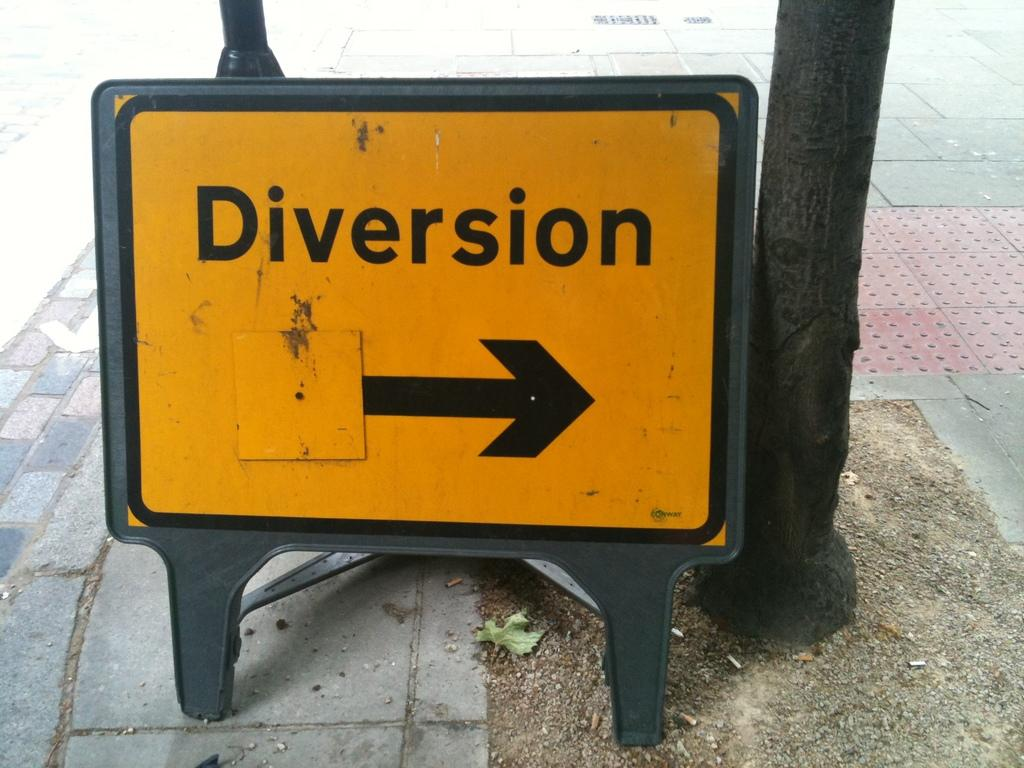What is present on the floor in the image? There is a sign board on the floor in the image. What type of glass is being smashed by the cannon in the image? There is no glass or cannon present in the image; it only features a sign board on the floor. 